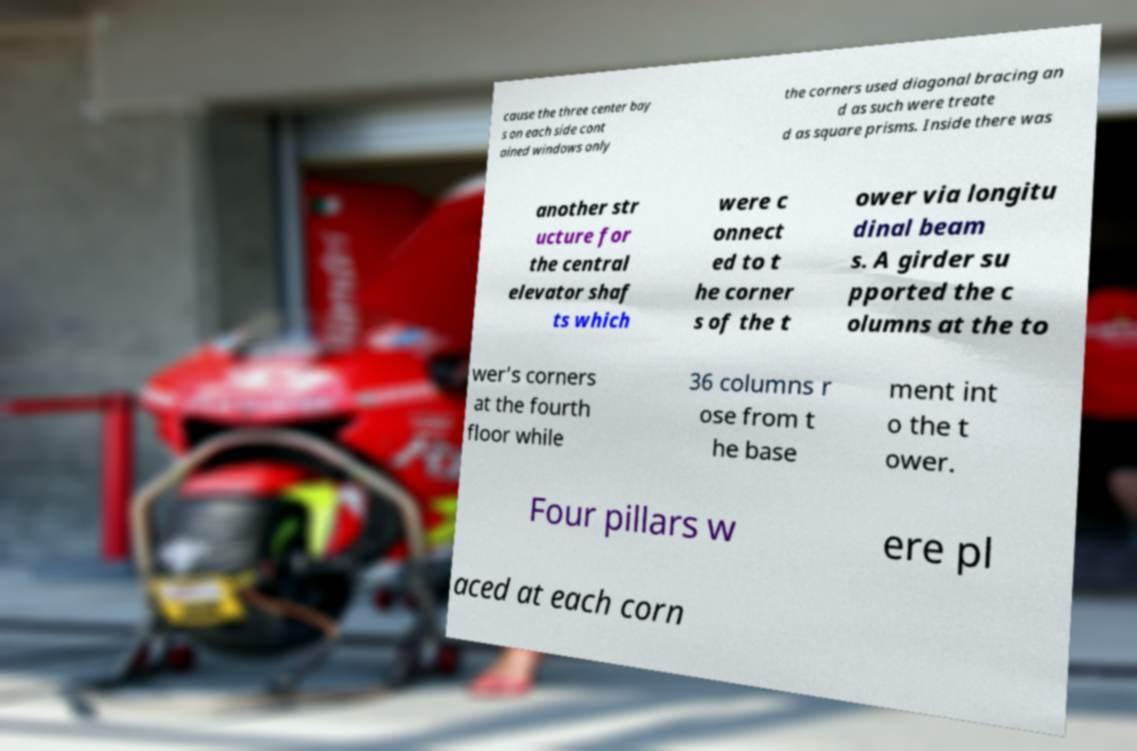Can you accurately transcribe the text from the provided image for me? cause the three center bay s on each side cont ained windows only the corners used diagonal bracing an d as such were treate d as square prisms. Inside there was another str ucture for the central elevator shaf ts which were c onnect ed to t he corner s of the t ower via longitu dinal beam s. A girder su pported the c olumns at the to wer’s corners at the fourth floor while 36 columns r ose from t he base ment int o the t ower. Four pillars w ere pl aced at each corn 